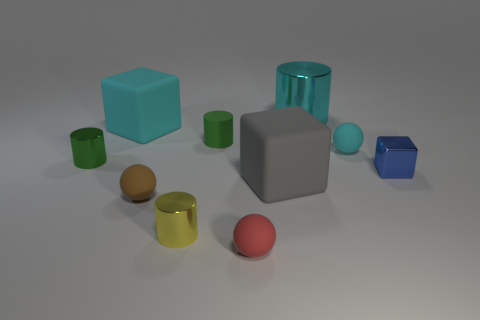There is a tiny thing that is the same color as the big cylinder; what is its material?
Provide a succinct answer. Rubber. What is the size of the object that is the same color as the matte cylinder?
Provide a short and direct response. Small. What material is the block that is both behind the gray object and in front of the tiny green rubber thing?
Give a very brief answer. Metal. What is the shape of the green object that is made of the same material as the red sphere?
Offer a terse response. Cylinder. Are there any other things that are the same color as the tiny shiny block?
Give a very brief answer. No. Are there more big cyan cylinders that are in front of the red ball than brown spheres?
Provide a short and direct response. No. What material is the tiny blue cube?
Give a very brief answer. Metal. What number of metal things have the same size as the green matte cylinder?
Provide a succinct answer. 3. Are there the same number of tiny green cylinders behind the cyan matte ball and cyan objects in front of the small green rubber thing?
Make the answer very short. Yes. Are the red ball and the small cyan object made of the same material?
Your response must be concise. Yes. 